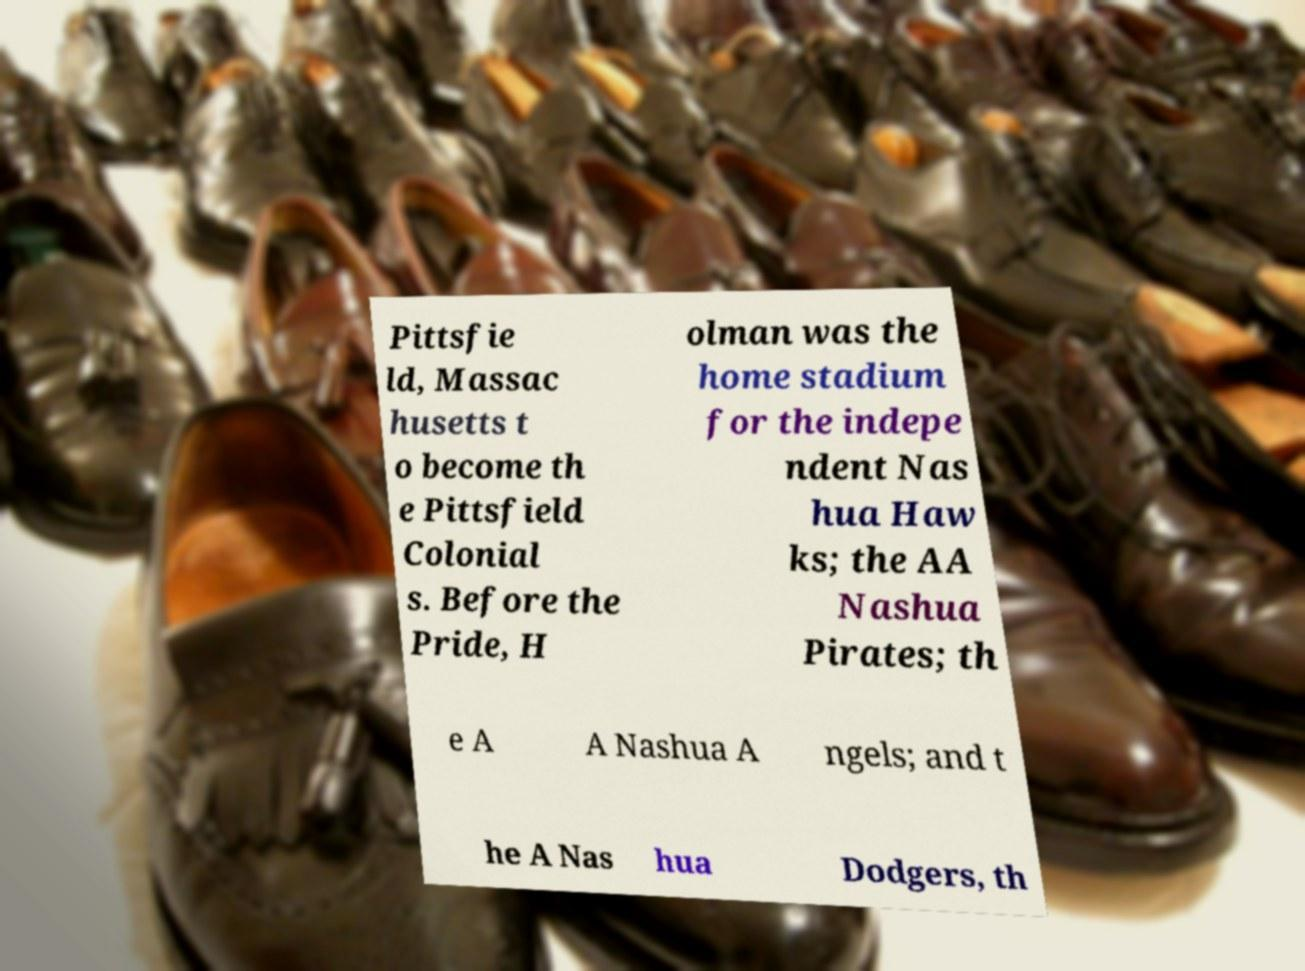Could you extract and type out the text from this image? Pittsfie ld, Massac husetts t o become th e Pittsfield Colonial s. Before the Pride, H olman was the home stadium for the indepe ndent Nas hua Haw ks; the AA Nashua Pirates; th e A A Nashua A ngels; and t he A Nas hua Dodgers, th 